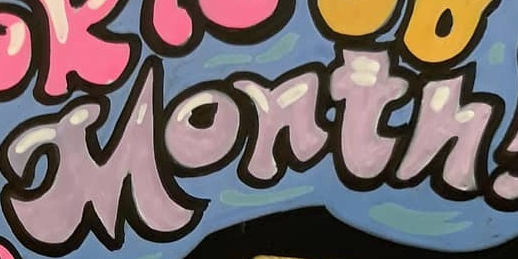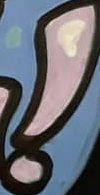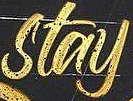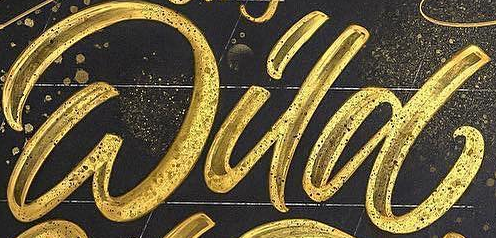What words can you see in these images in sequence, separated by a semicolon? Month; !; stay; Wild 